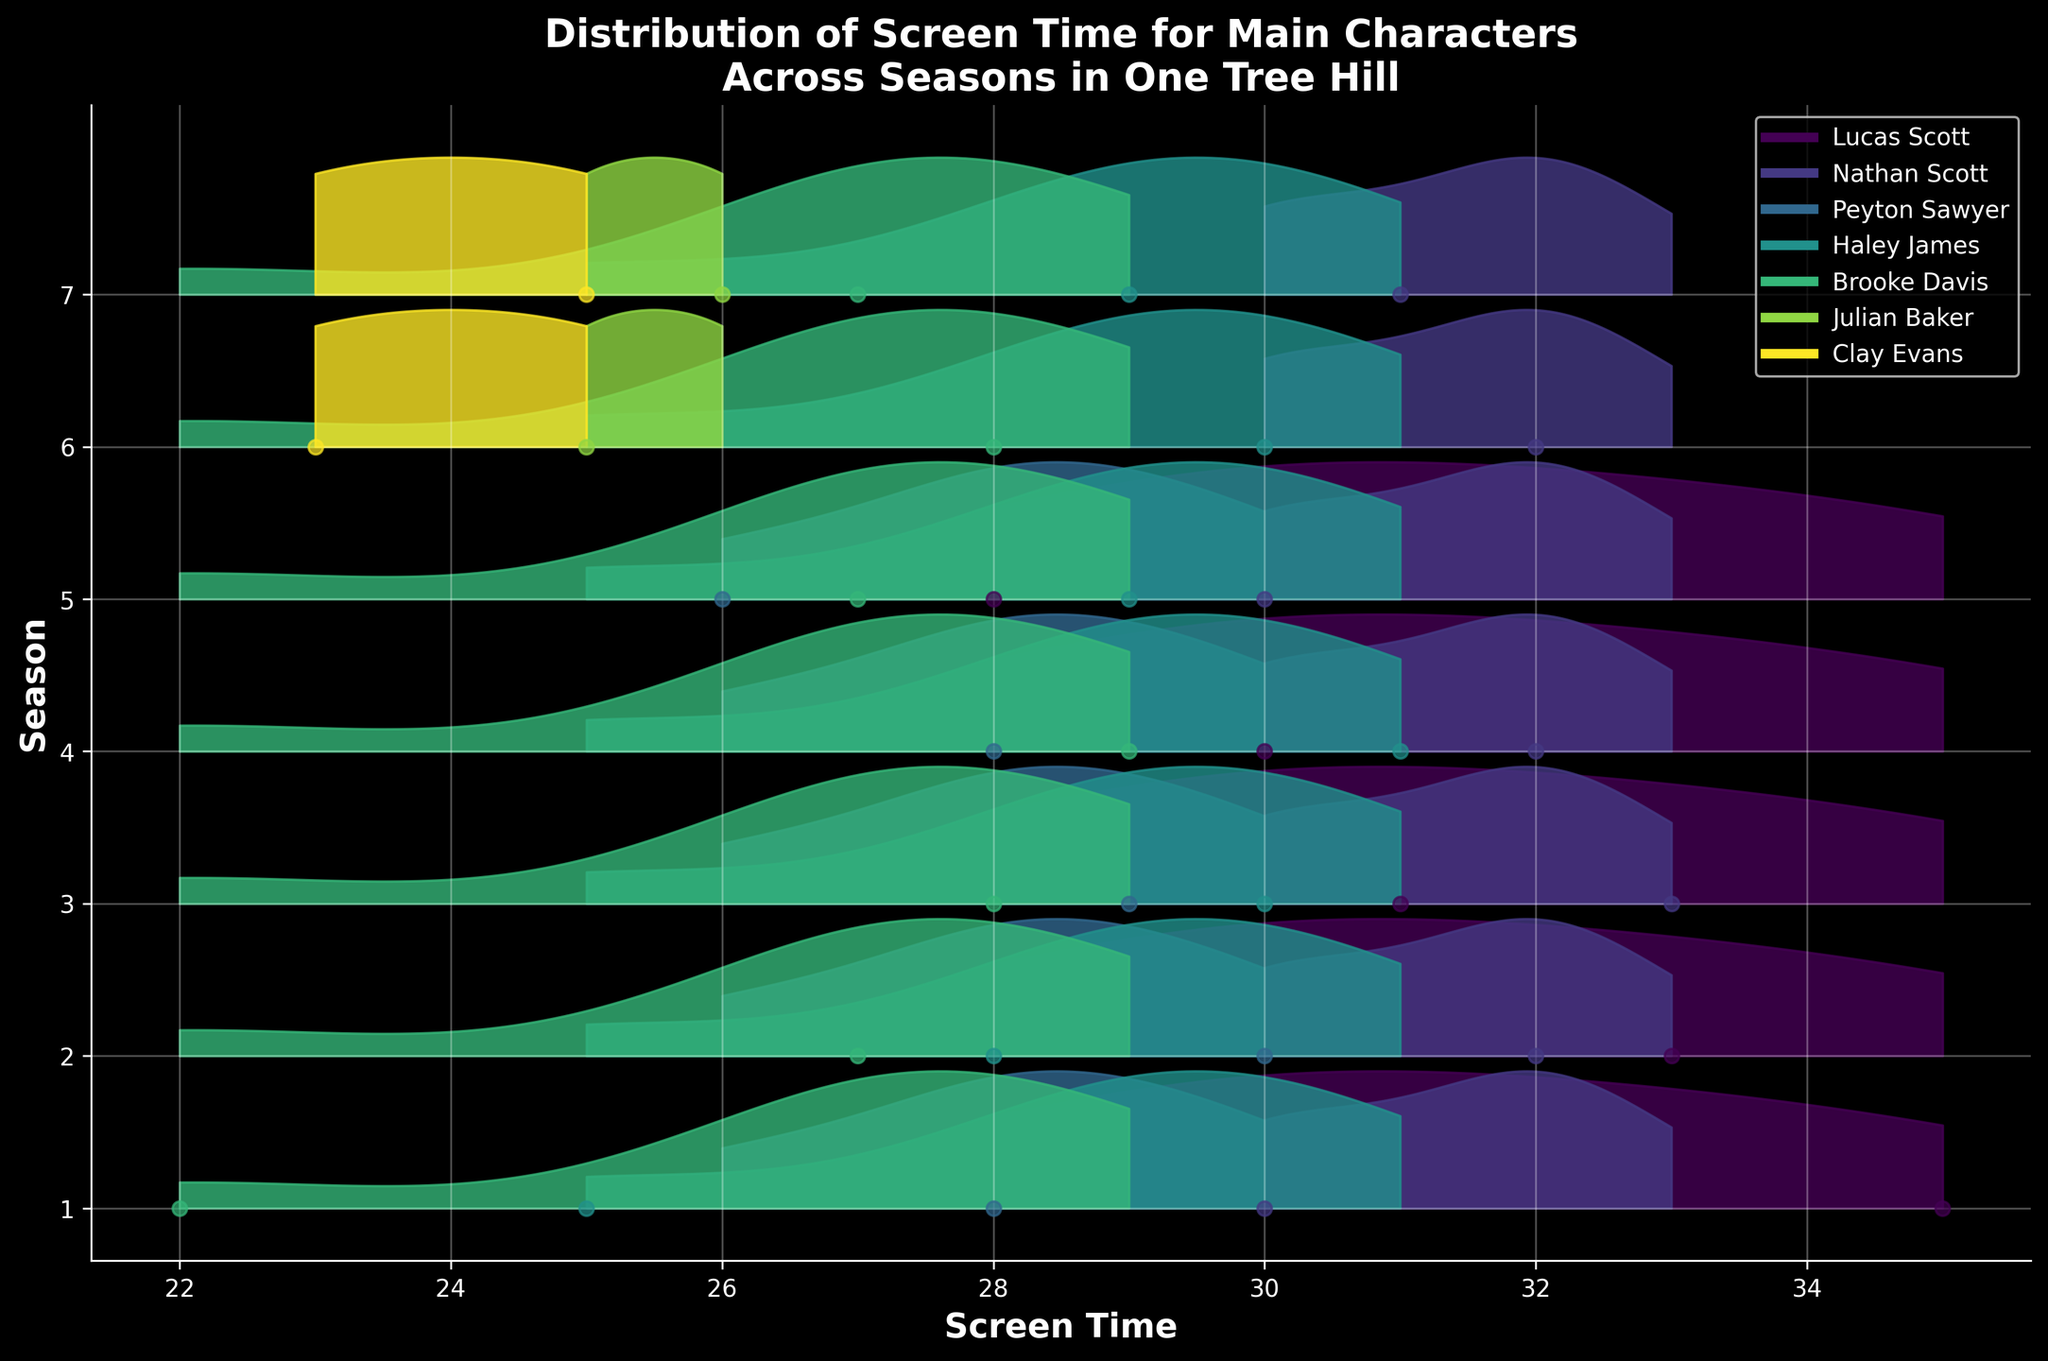What's the title of the plot? The title is usually located at the top of the plot, which provides a brief description of what the plot is about.
Answer: Distribution of Screen Time for Main Characters Across Seasons in One Tree Hill What are the x-axis and y-axis labels in the plot? The x-axis is usually horizontal and the y-axis is vertical. The labels give information about what each axis represents. In this plot, the x-axis represents screen time and the y-axis represents seasons.
Answer: x-axis: Screen Time, y-axis: Season Which character has the most consistent screen time across seasons? By looking at the density curves for each character across seasons, we should identify the character whose screen time values show the least variation between seasons. Brooke Davis has a relatively consistent screen time.
Answer: Brooke Davis Which season had the highest overall screen time for Lucas Scott? Find the peak of the density curve for each season that Lucas Scott appears in and identify the highest value. The curve for Season 1 is the highest.
Answer: Season 1 Who has the highest screen time in Season 6? Look at the filled areas for Season 6 and note the character whose density curve reaches the highest point. Nathan Scott leads in Season 6.
Answer: Nathan Scott Did Nathan Scott's screen time increase, decrease, or stay the same from Season 1 to Season 7? Compare the positions of Nathan Scott’s density peaks in Seasons 1 and 7 to see if they show an increasing, decreasing trend or stay about the same. Nathan's screen time slightly decreased from Season 1 to Season 7.
Answer: Decrease In which seasons did Julian Baker have screen time and how much was it? Look for the filled areas associated with Julian Baker’s color and identify the seasons they appear in as well as the approximate values from the respective density curves. Julian Baker appeared in Seasons 6 and 7 with screen times approximately 25 and 26 minutes respectively.
Answer: Seasons 6 and 7, 25 and 26 minutes What is the range of screen time for Haley James in Season 5? Check the spread of Haley James’ density curve in Season 5 to determine the range of screen time values. Haley has a screen time between approximately 26 and 29 minutes in Season 5.
Answer: 26 to 29 minutes Which character's screen time shows the most variation across the seasons? Compare the width of the density curves across characters, focusing on how spread apart the peaks and valleys are for each character across all seasons. Peyton Sawyer shows relatively significant variation.
Answer: Peyton Sawyer 